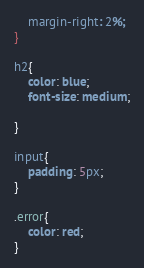<code> <loc_0><loc_0><loc_500><loc_500><_CSS_>    margin-right: 2%;
}

h2{
    color: blue;
    font-size: medium;

}

input{
    padding: 5px;
}

.error{
    color: red;
}</code> 